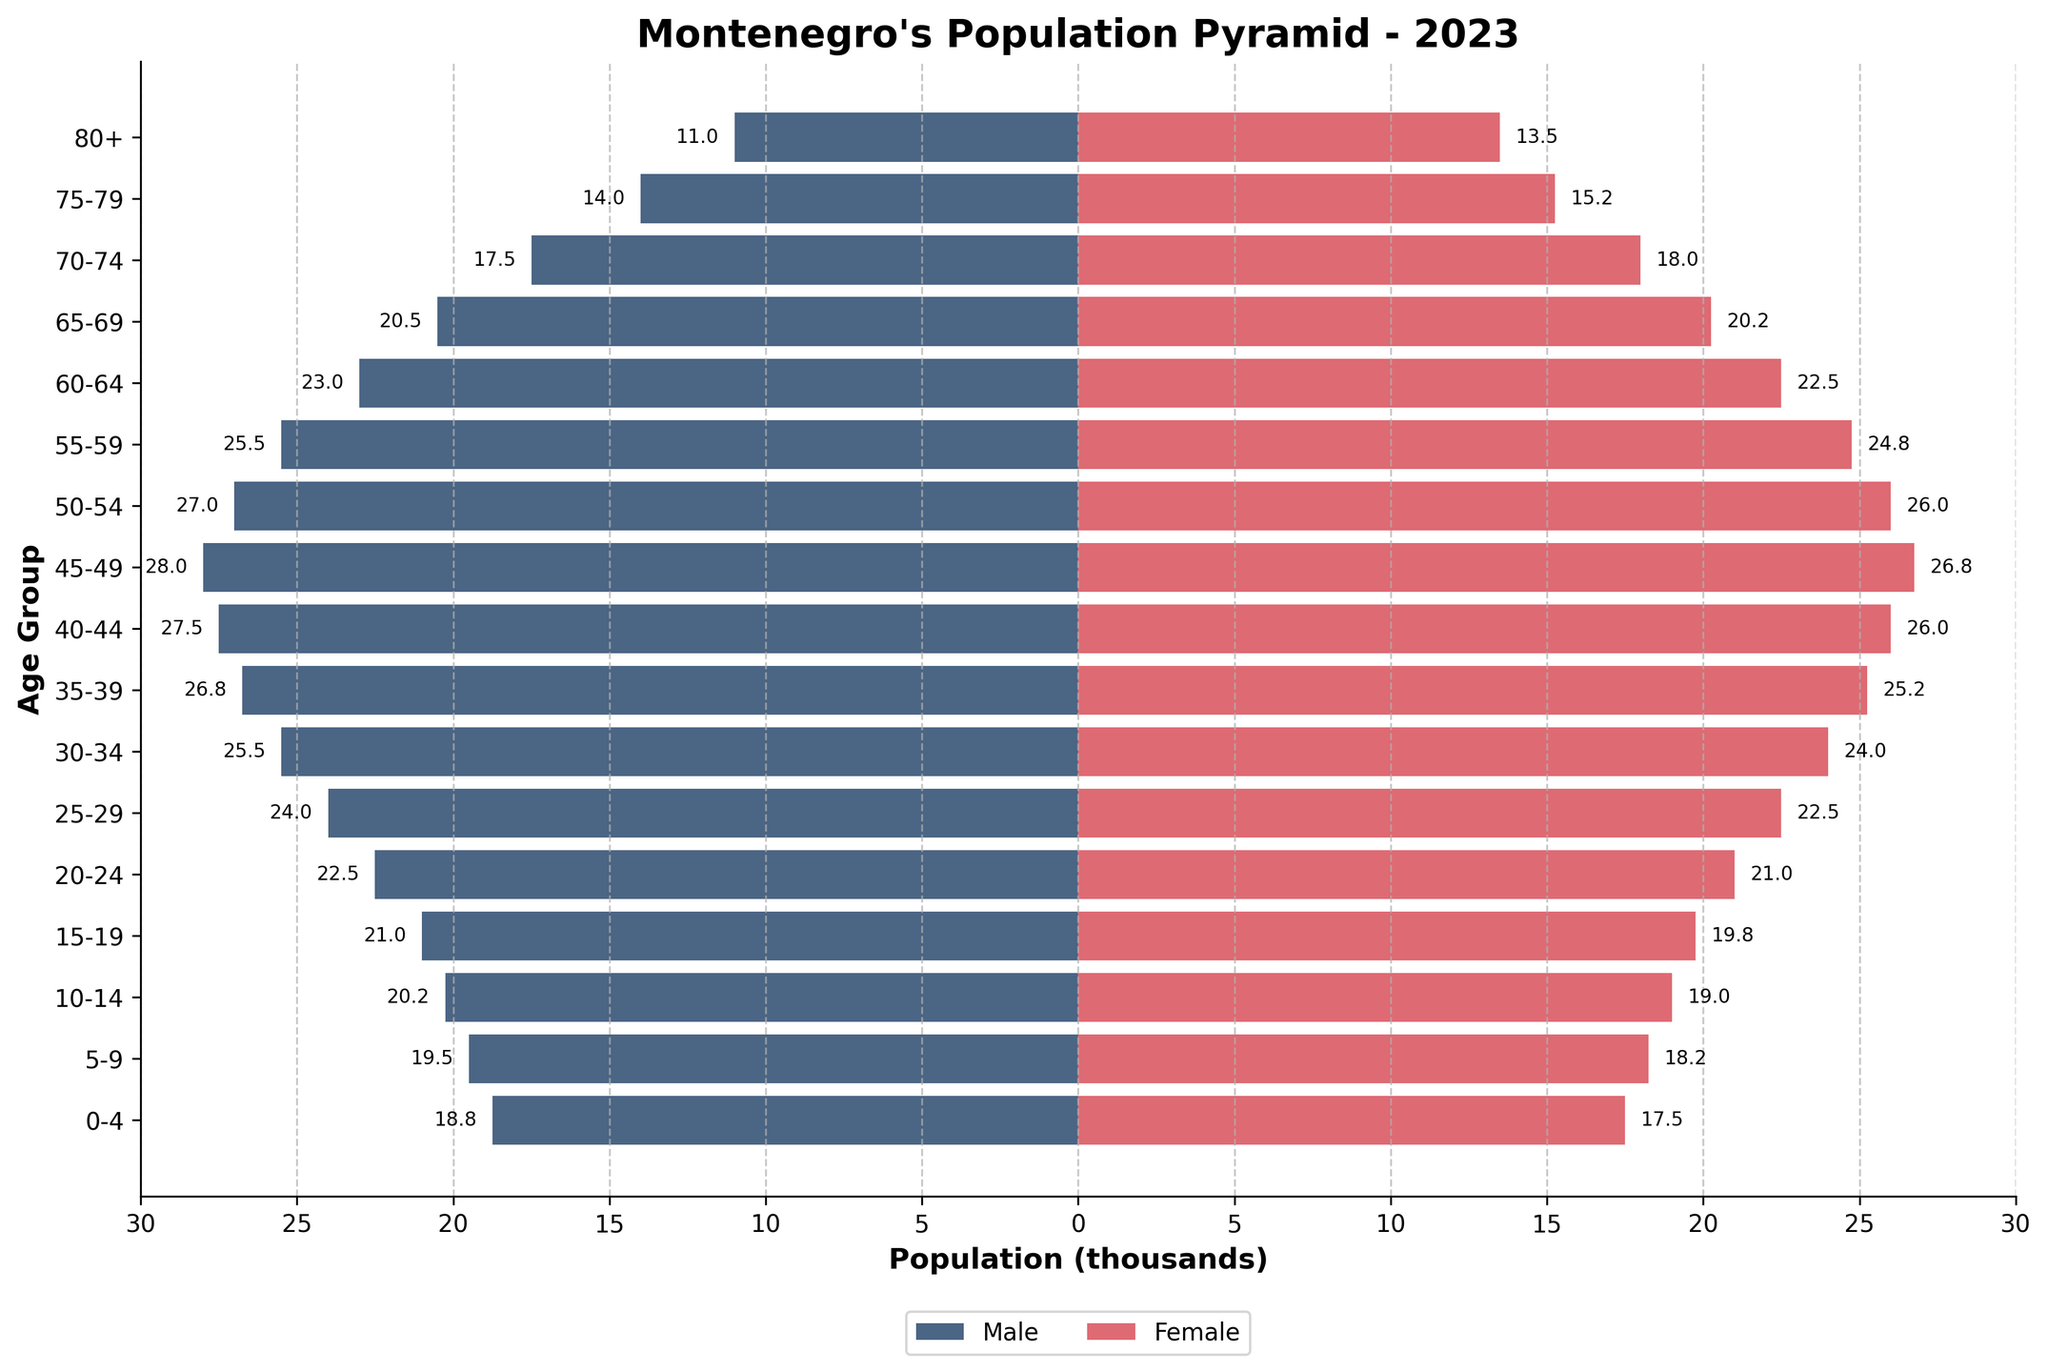What is the title of the plot? The title is usually one of the key visible elements at the top of the plot. It helps to succinctly describe what the data visualization represents.
Answer: Montenegro's Population Pyramid - 2023 Which age group has the highest male population? To find the age group with the highest male population, look for the age category corresponding to the longest male bar toward the left side of the plot.
Answer: 45-49 Is there any age group where the female population is higher than the male population? If yes, which one(s)? Scan the bars for each age group to see if the female bar extends further than the male bar at any point. The comparison should be done visually.
Answer: 70-74, 75-79, 80+ What is the total population (in thousands) for the age group 30-34? Add the values of the male and female population for the 30-34 age group. From the data, it's 25,500 males and 24,000 females, so the total is 25.5 + 24.0.
Answer: 49.5 Between which age groups does the gender distribution appear most equal? Examine age groups where the male and female bars are nearly the same length, indicating similar population sizes.
Answer: 55-59 How does the population change as age increases from 0-4 to 80+ for both males and females? Note the trend in bar lengths for both males and females as you move from the bottom (youngest) to the top (oldest) age groups. The general trend shows the population decreasing with age.
Answer: Decreasing What is the average population of males from age 10-19? Take the male population from the 10-14 and 15-19 age groups and compute the average. That's (20,250 + 21,000) / 2.
Answer: 20,625 How much larger is the population of males compared to females in the age group 25-29? Subtract the female population from the male population for the 25-29 age group. From the data, it's 24,000 males and 22,500 females, so the difference is 24,000 - 22,500.
Answer: 1,500 What does the x-axis represent in this plot? The x-axis label is explicitly shown and it relates to the measure of population size in thousands.
Answer: Population (thousands) Do any age groups show a significant gender imbalance? Which ones? Look for age groups where there is a noticeable disparity in bar lengths between males and females, indicating significant gender imbalance.
Answer: 20-24, 70-74, 75-79, 80+ 